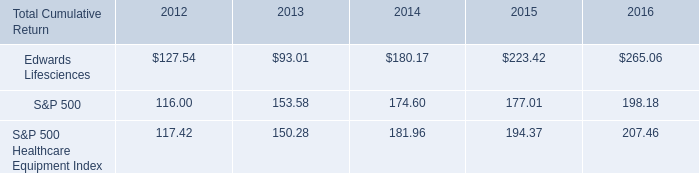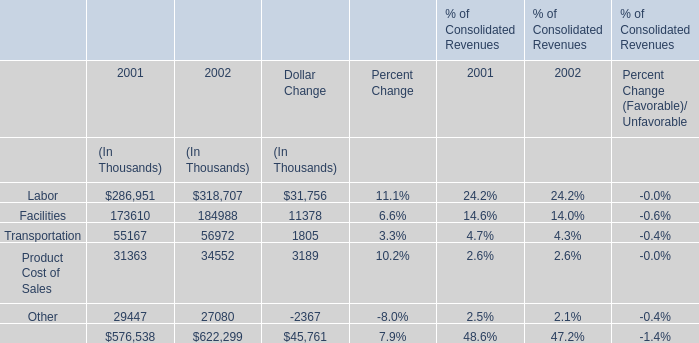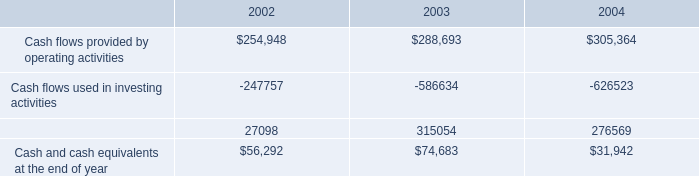If Facilities's percent of Consolidated Revenues develops with the same growth rate in 2002, what will it reach in 2003? (in %) 
Computations: (14 + ((14.0 - 14.6) / 14.6))
Answer: 13.9589. 